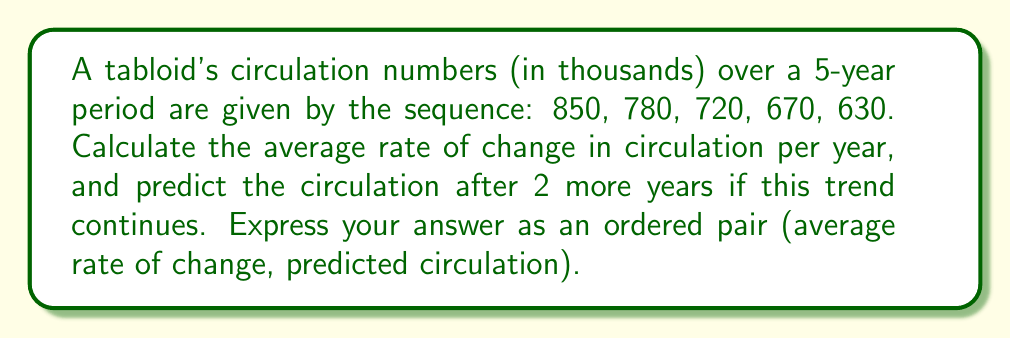Give your solution to this math problem. 1) To calculate the average rate of change, we use the formula:

   $$\text{Average rate of change} = \frac{\text{Total change}}{\text{Number of intervals}}$$

2) Total change in circulation:
   $$630 - 850 = -220\text{ thousand}$$

3) Number of intervals (years): 4

4) Average rate of change:
   $$\frac{-220}{4} = -55\text{ thousand per year}$$

5) To predict the circulation after 2 more years, we extend the trend:
   
   Current circulation: 630 thousand
   Change over 2 years: $2 \times (-55) = -110\text{ thousand}$
   
   Predicted circulation: $630 - 110 = 520\text{ thousand}$

6) Therefore, the answer is $(-55, 520)$, where -55 is the average rate of change in thousands per year, and 520 is the predicted circulation in thousands after 2 more years.
Answer: $(-55, 520)$ 